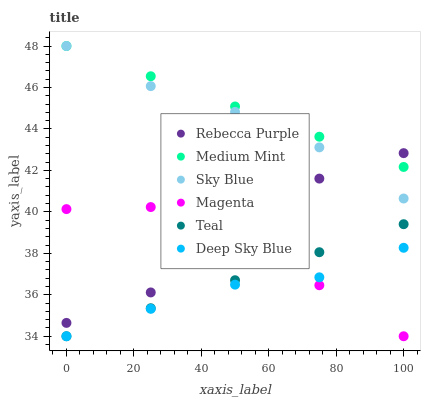Does Deep Sky Blue have the minimum area under the curve?
Answer yes or no. Yes. Does Medium Mint have the maximum area under the curve?
Answer yes or no. Yes. Does Rebecca Purple have the minimum area under the curve?
Answer yes or no. No. Does Rebecca Purple have the maximum area under the curve?
Answer yes or no. No. Is Teal the smoothest?
Answer yes or no. Yes. Is Rebecca Purple the roughest?
Answer yes or no. Yes. Is Deep Sky Blue the smoothest?
Answer yes or no. No. Is Deep Sky Blue the roughest?
Answer yes or no. No. Does Deep Sky Blue have the lowest value?
Answer yes or no. Yes. Does Rebecca Purple have the lowest value?
Answer yes or no. No. Does Sky Blue have the highest value?
Answer yes or no. Yes. Does Rebecca Purple have the highest value?
Answer yes or no. No. Is Magenta less than Sky Blue?
Answer yes or no. Yes. Is Rebecca Purple greater than Teal?
Answer yes or no. Yes. Does Medium Mint intersect Rebecca Purple?
Answer yes or no. Yes. Is Medium Mint less than Rebecca Purple?
Answer yes or no. No. Is Medium Mint greater than Rebecca Purple?
Answer yes or no. No. Does Magenta intersect Sky Blue?
Answer yes or no. No. 